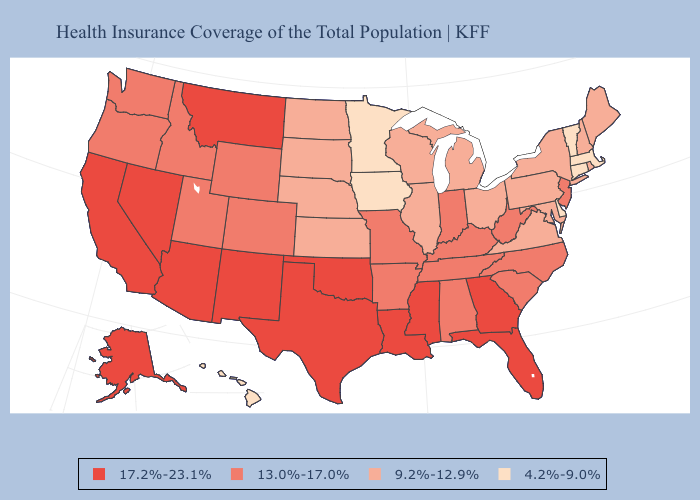What is the highest value in the West ?
Be succinct. 17.2%-23.1%. Which states hav the highest value in the Northeast?
Write a very short answer. New Jersey. What is the highest value in states that border Oklahoma?
Keep it brief. 17.2%-23.1%. Among the states that border Georgia , which have the lowest value?
Short answer required. Alabama, North Carolina, South Carolina, Tennessee. What is the lowest value in the South?
Write a very short answer. 4.2%-9.0%. What is the lowest value in the USA?
Write a very short answer. 4.2%-9.0%. Name the states that have a value in the range 17.2%-23.1%?
Be succinct. Alaska, Arizona, California, Florida, Georgia, Louisiana, Mississippi, Montana, Nevada, New Mexico, Oklahoma, Texas. Name the states that have a value in the range 4.2%-9.0%?
Quick response, please. Connecticut, Delaware, Hawaii, Iowa, Massachusetts, Minnesota, Vermont. Does Hawaii have the lowest value in the USA?
Be succinct. Yes. Which states hav the highest value in the MidWest?
Concise answer only. Indiana, Missouri. What is the lowest value in the USA?
Concise answer only. 4.2%-9.0%. What is the lowest value in states that border Wisconsin?
Answer briefly. 4.2%-9.0%. What is the value of Indiana?
Quick response, please. 13.0%-17.0%. Name the states that have a value in the range 17.2%-23.1%?
Be succinct. Alaska, Arizona, California, Florida, Georgia, Louisiana, Mississippi, Montana, Nevada, New Mexico, Oklahoma, Texas. 